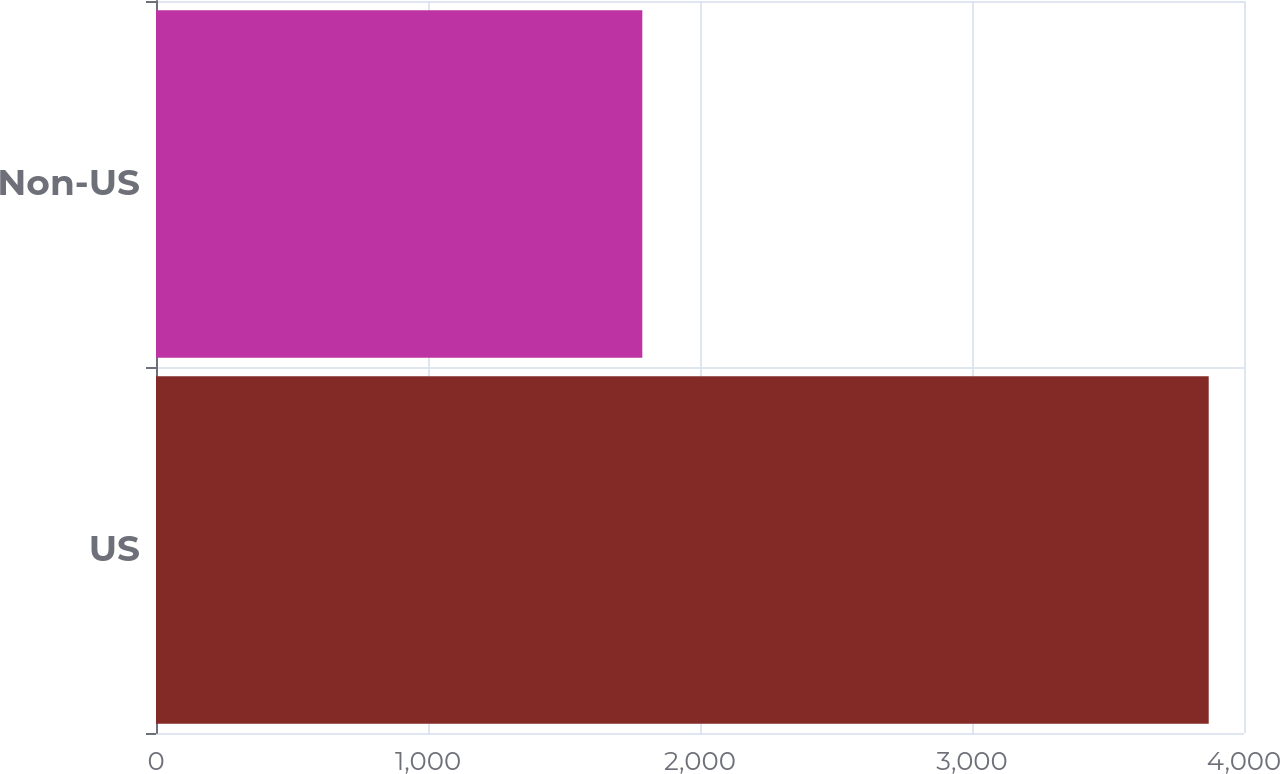Convert chart to OTSL. <chart><loc_0><loc_0><loc_500><loc_500><bar_chart><fcel>US<fcel>Non-US<nl><fcel>3870.3<fcel>1787.9<nl></chart> 